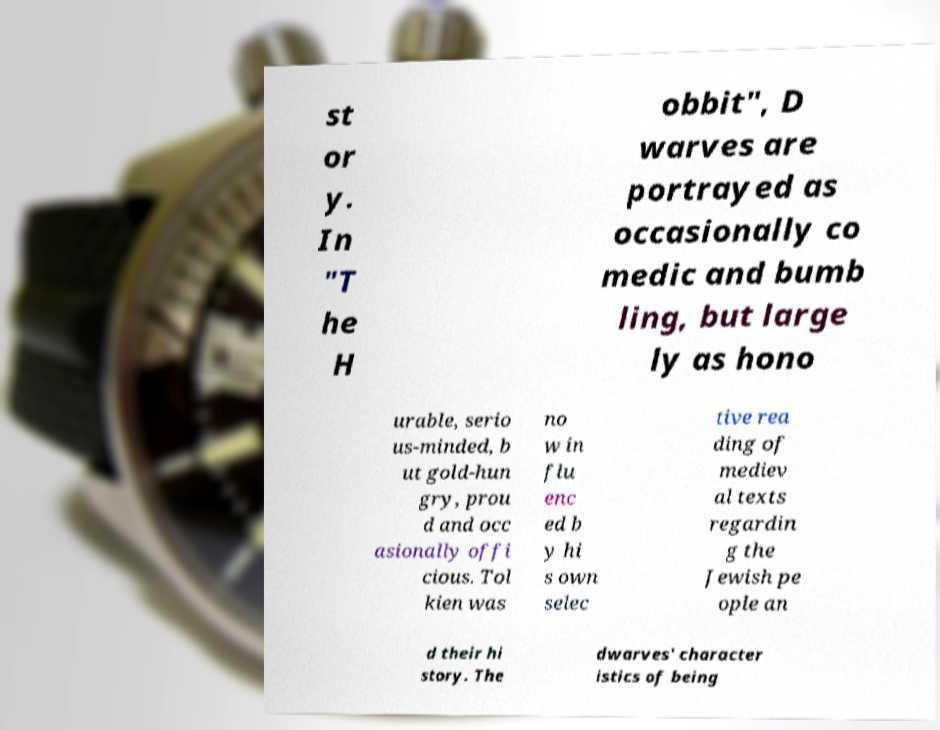Please read and relay the text visible in this image. What does it say? st or y. In "T he H obbit", D warves are portrayed as occasionally co medic and bumb ling, but large ly as hono urable, serio us-minded, b ut gold-hun gry, prou d and occ asionally offi cious. Tol kien was no w in flu enc ed b y hi s own selec tive rea ding of mediev al texts regardin g the Jewish pe ople an d their hi story. The dwarves' character istics of being 